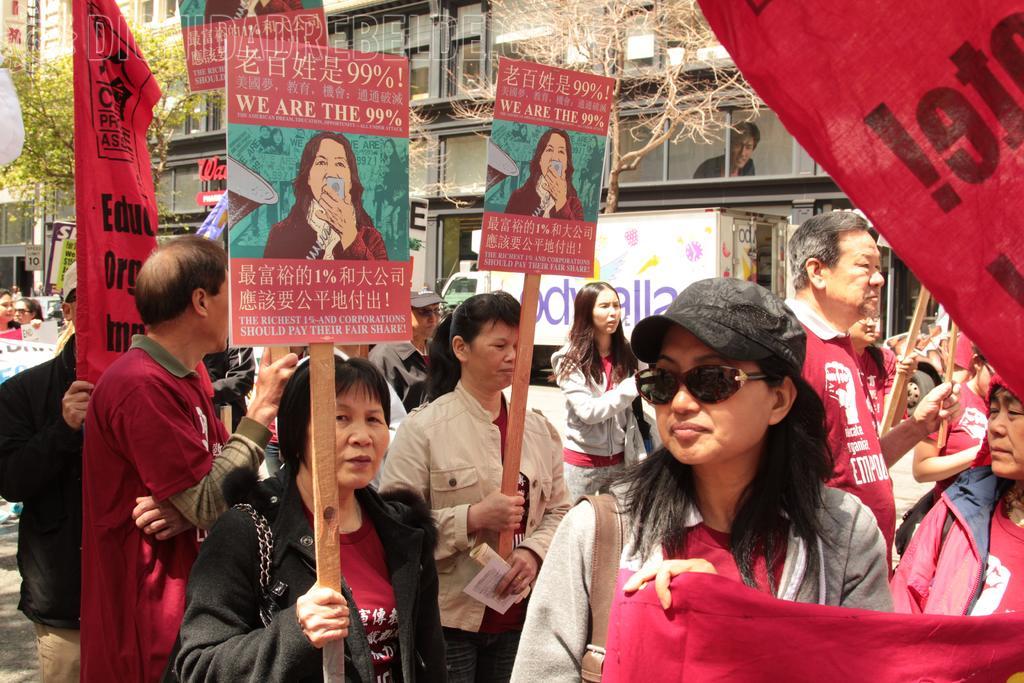Can you describe this image briefly? In the image there is a crowd standing on the road and they are holding some flags and boards in their hand, it looks like they are protesting against something, in the background there is a vehicle and behind the vehicle there is a building, on the left side there is a tree. 